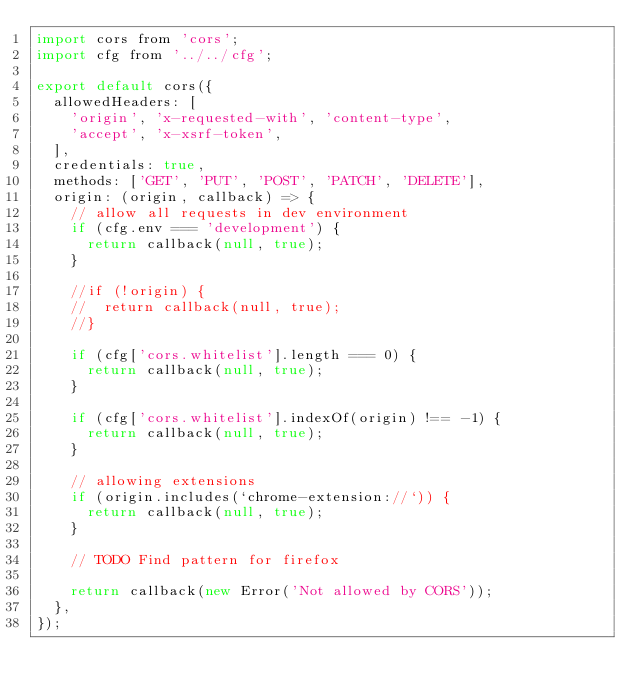<code> <loc_0><loc_0><loc_500><loc_500><_JavaScript_>import cors from 'cors';
import cfg from '../../cfg';

export default cors({
  allowedHeaders: [
    'origin', 'x-requested-with', 'content-type',
    'accept', 'x-xsrf-token',
  ],
  credentials: true,
  methods: ['GET', 'PUT', 'POST', 'PATCH', 'DELETE'],
  origin: (origin, callback) => {
    // allow all requests in dev environment
    if (cfg.env === 'development') {
      return callback(null, true);
    }

    //if (!origin) {
    //  return callback(null, true);
    //}

    if (cfg['cors.whitelist'].length === 0) {
      return callback(null, true);
    }

    if (cfg['cors.whitelist'].indexOf(origin) !== -1) {
      return callback(null, true);
    }

    // allowing extensions
    if (origin.includes(`chrome-extension://`)) {
      return callback(null, true);
    }

    // TODO Find pattern for firefox

    return callback(new Error('Not allowed by CORS'));
  },
});
</code> 